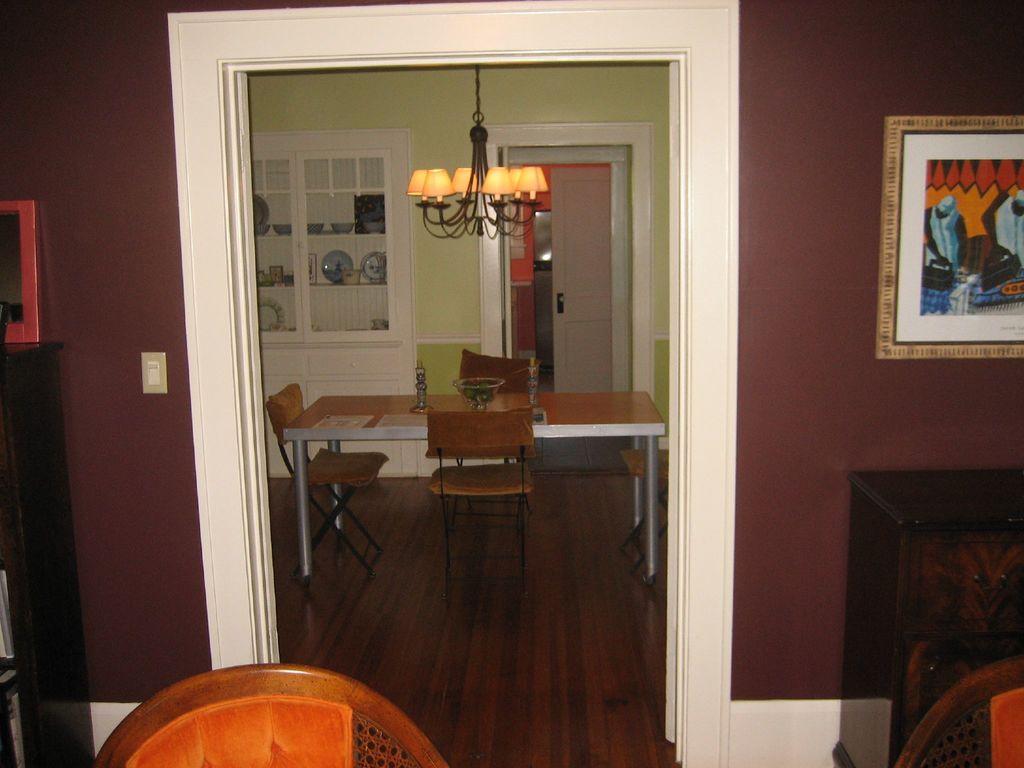Can you describe this image briefly? In the foreground, I can see chairs, door, wall painting on a wall and a table on which some objects are there. In the background, I can see a chandelier, shelves in which utensils are there and so on. This picture might be taken in a room. 